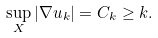<formula> <loc_0><loc_0><loc_500><loc_500>\sup _ { X } | \nabla u _ { k } | = C _ { k } \geq k .</formula> 